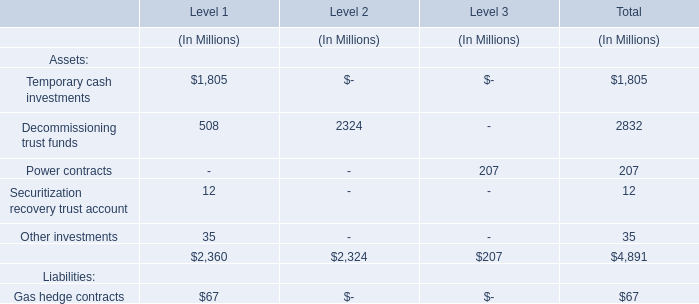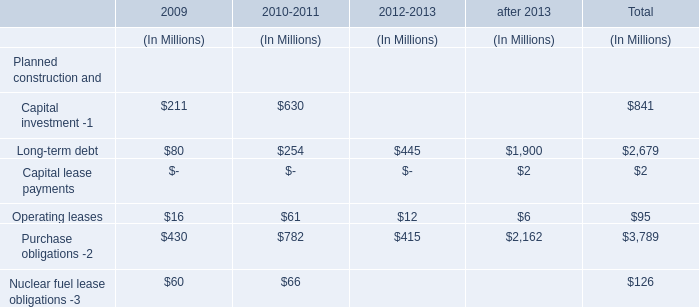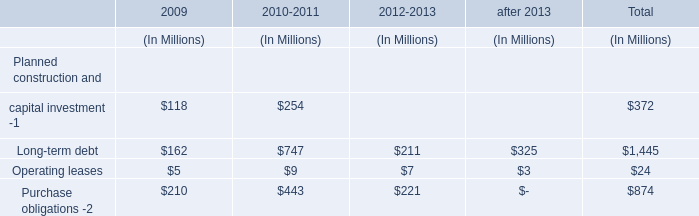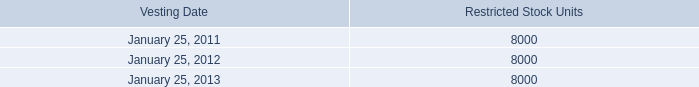What was the total amount of Temporary cash investments, Decommissioning trust funds, Securitization recovery trust account and Other investments for Level 1? (in Million) 
Computations: (((1805 + 508) + 12) + 35)
Answer: 2360.0. 